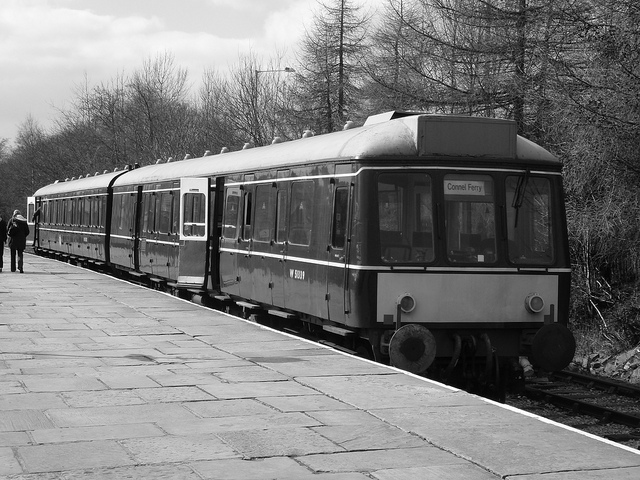How is this train significant? Trains like the one in the image are significant as they represent a historical period of rail transport. They are often cherished by railway enthusiasts and the general public for their heritage and nostalgic value. They also serve as a physical record of the technological and design advancements of their time. 